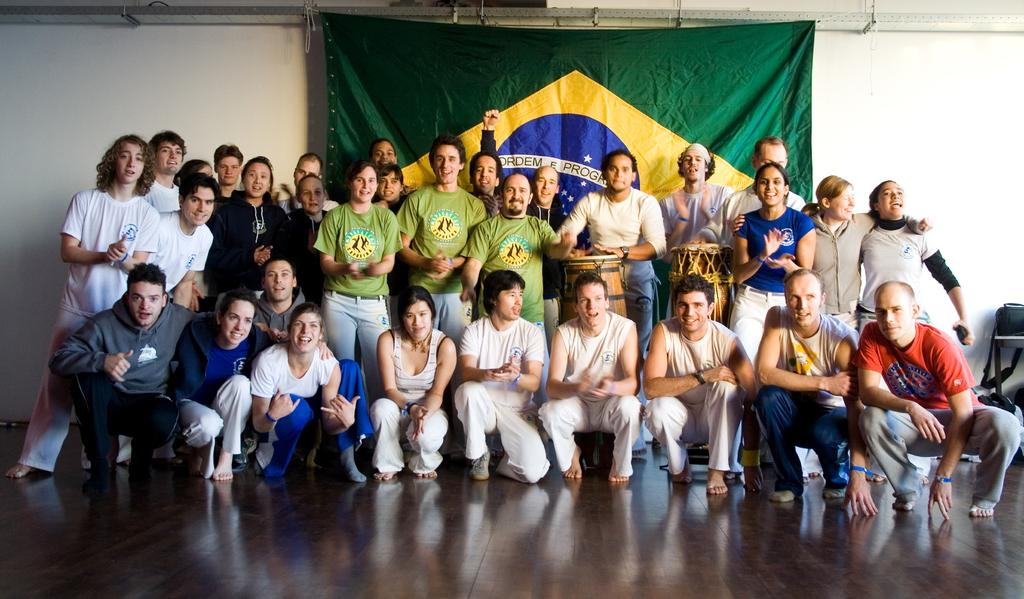What are the people in the image doing? The people in the image are standing and sitting in the center of the image. What objects can be seen in the image? There are drums in the image. What can be seen in the background of the image? There is a cloth and a wall in the background of the image. How does the stream flow through the image? There is no stream present in the image; it only features people, drums, a cloth, and a wall. What type of body is visible in the image? There are no bodies visible in the image, only people, drums, a cloth, and a wall. 